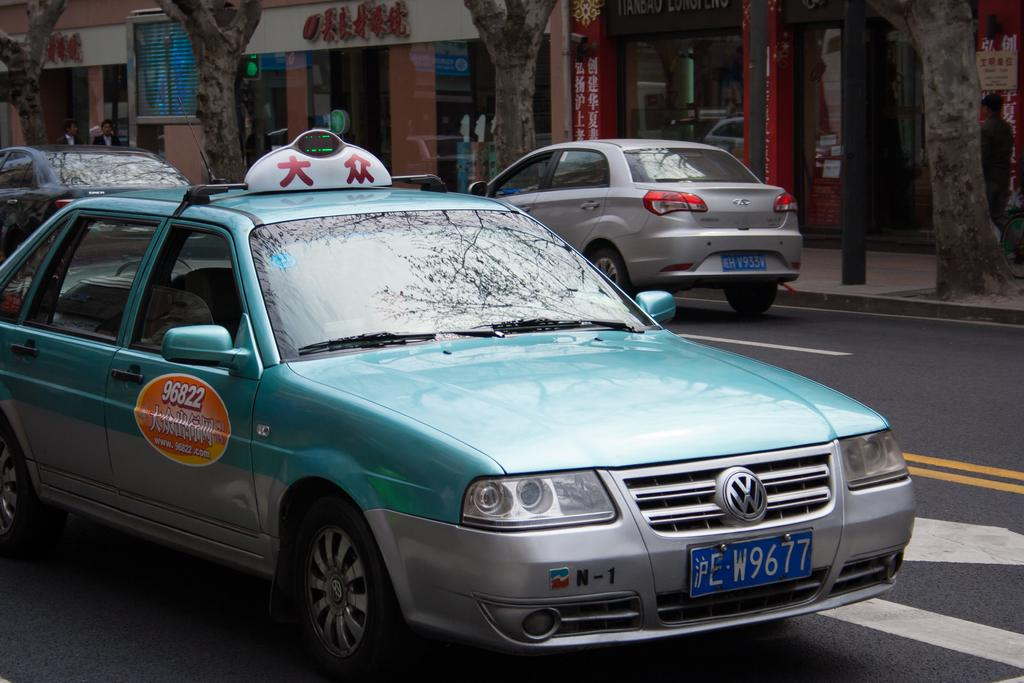Provide a one-sentence caption for the provided image. green volskvagon taxi car driving on the street. 